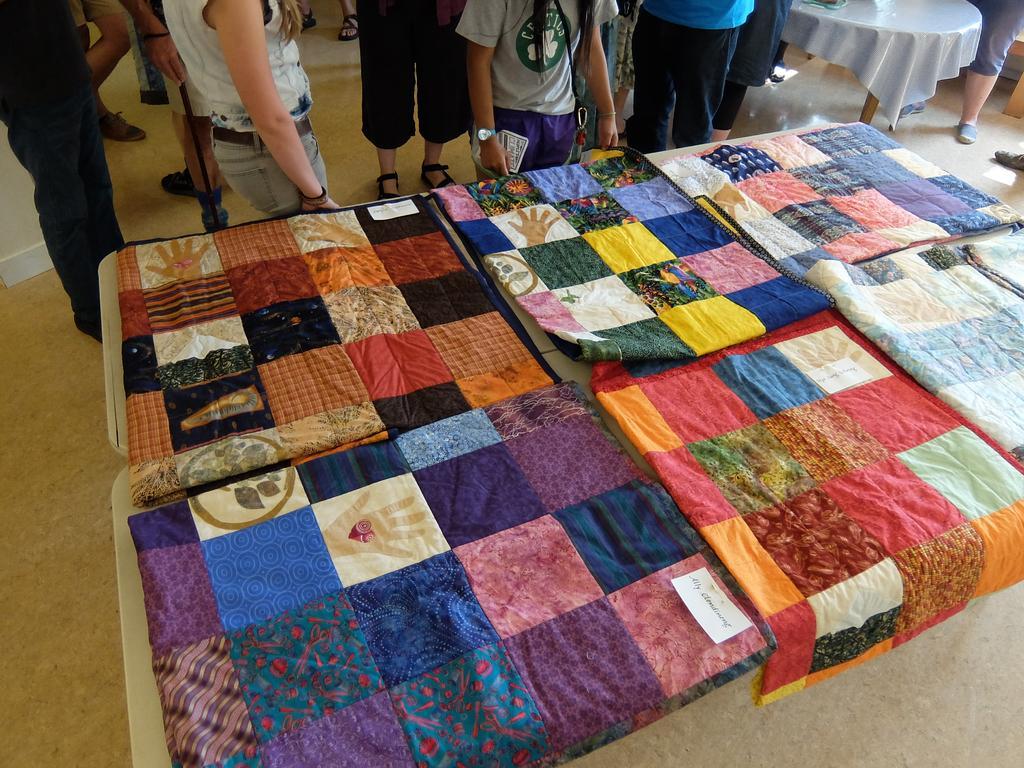Can you describe this image briefly? In this picture I can see many blankets which are kept on the table. At the top I can see many men and women are standing on the floor. In the top right corner I can see the round table which is placed near to the bench. 